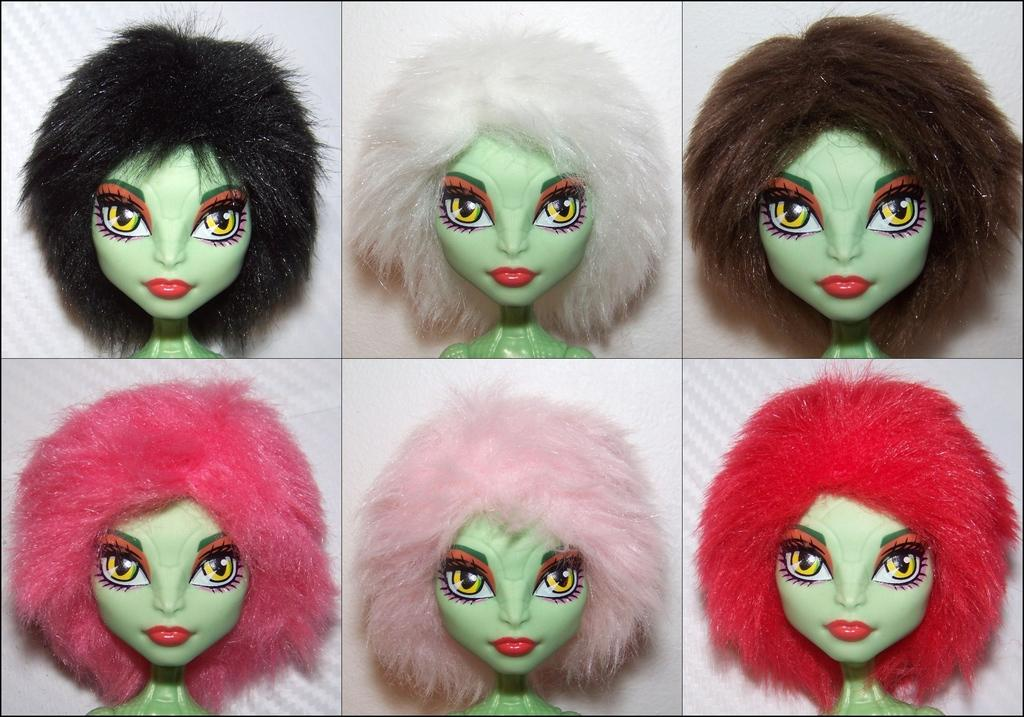What type of image is shown in the picture? The image is a photo collage. What can be observed about the doll in the collage? There are different color hairs for a green color doll in the collage. How many cats are sitting on the foot of the doll in the image? There are no cats or feet visible in the image, as it is a photo collage featuring a green color doll with different color hairs. 